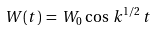Convert formula to latex. <formula><loc_0><loc_0><loc_500><loc_500>W ( t ) \, = \, W _ { 0 } \, \cos \, k ^ { 1 / 2 } \, t</formula> 